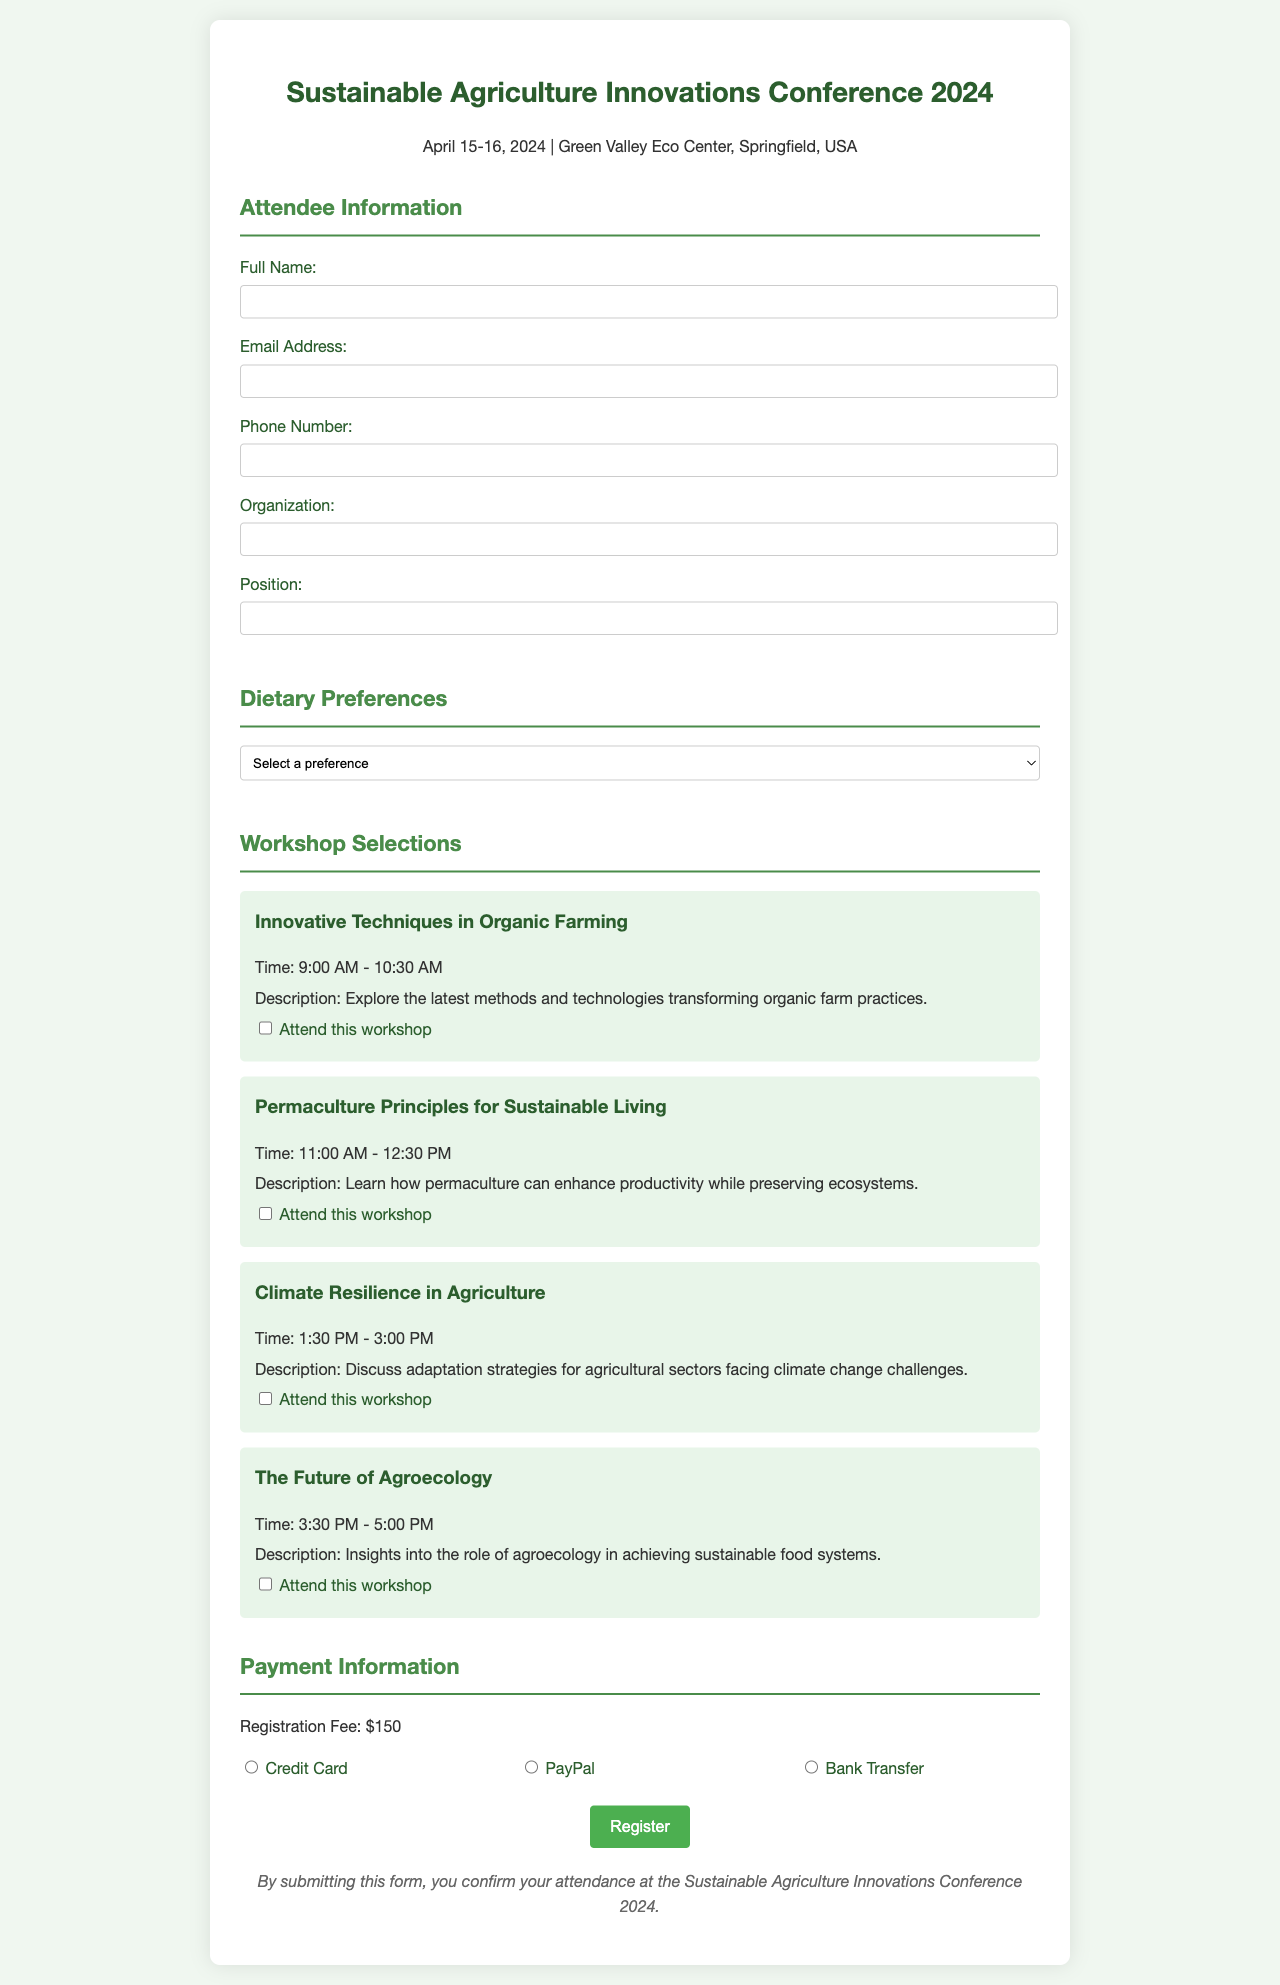What are the conference dates? The conference dates are specified in the document, which states that it will take place on April 15-16, 2024.
Answer: April 15-16, 2024 What is the registration fee? The registration fee is stated in the payment information section of the document.
Answer: $150 What dietary preferences are available? The document lists different options for dietary preferences in a dropdown menu.
Answer: Vegan, Vegetarian, Gluten-Free, Nut-Free, None, Other What payment methods are accepted? The document provides three options for payment methods that are listed in the payment information section.
Answer: Credit Card, PayPal, Bank Transfer How many workshops can attendees select? Attendees can select one or more workshops, as indicated by the checkboxes provided in the document.
Answer: Multiple What is the focus of the workshop titled "Climate Resilience in Agriculture"? This workshop's focus is detailed in the description provided in the workshop section.
Answer: Adaptation strategies for agricultural sectors facing climate change challenges What time does the "Innovative Techniques in Organic Farming" workshop start? The workshop times are listed in the document and specifically for this workshop.
Answer: 9:00 AM What type of event is this document related to? The information presented in the heading and introductory parts of the document indicates the nature of the event.
Answer: Conference 